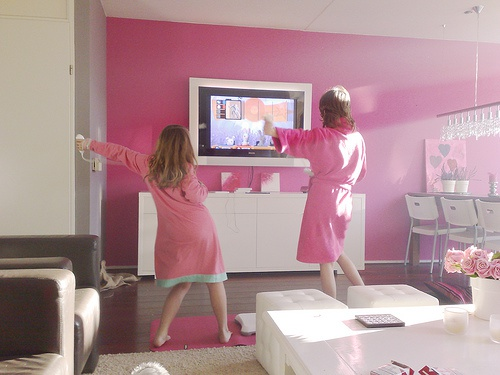Describe the objects in this image and their specific colors. I can see people in tan, brown, lightpink, and maroon tones, people in tan, violet, brown, lightpink, and white tones, tv in tan, lavender, gray, and darkgray tones, couch in tan, black, lightgray, and darkgray tones, and chair in tan, gray, black, and white tones in this image. 